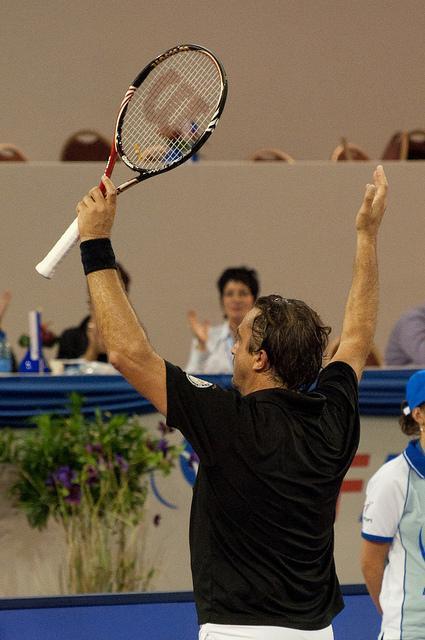How many people are there?
Give a very brief answer. 3. How many giraffes are shown?
Give a very brief answer. 0. 